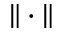<formula> <loc_0><loc_0><loc_500><loc_500>\| \cdot \|</formula> 